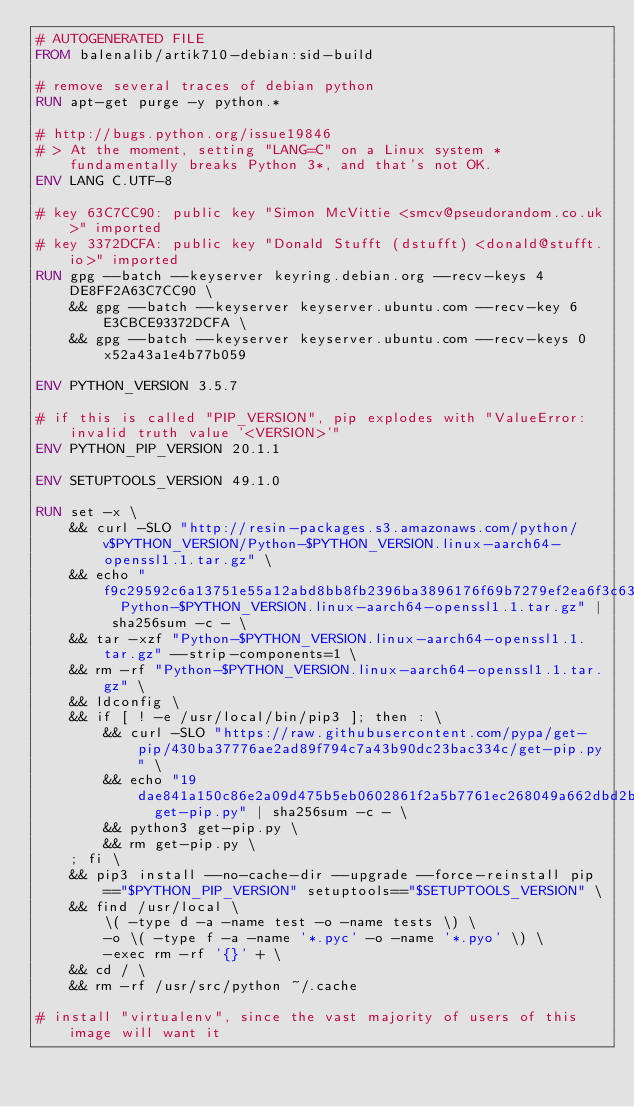Convert code to text. <code><loc_0><loc_0><loc_500><loc_500><_Dockerfile_># AUTOGENERATED FILE
FROM balenalib/artik710-debian:sid-build

# remove several traces of debian python
RUN apt-get purge -y python.*

# http://bugs.python.org/issue19846
# > At the moment, setting "LANG=C" on a Linux system *fundamentally breaks Python 3*, and that's not OK.
ENV LANG C.UTF-8

# key 63C7CC90: public key "Simon McVittie <smcv@pseudorandom.co.uk>" imported
# key 3372DCFA: public key "Donald Stufft (dstufft) <donald@stufft.io>" imported
RUN gpg --batch --keyserver keyring.debian.org --recv-keys 4DE8FF2A63C7CC90 \
	&& gpg --batch --keyserver keyserver.ubuntu.com --recv-key 6E3CBCE93372DCFA \
	&& gpg --batch --keyserver keyserver.ubuntu.com --recv-keys 0x52a43a1e4b77b059

ENV PYTHON_VERSION 3.5.7

# if this is called "PIP_VERSION", pip explodes with "ValueError: invalid truth value '<VERSION>'"
ENV PYTHON_PIP_VERSION 20.1.1

ENV SETUPTOOLS_VERSION 49.1.0

RUN set -x \
	&& curl -SLO "http://resin-packages.s3.amazonaws.com/python/v$PYTHON_VERSION/Python-$PYTHON_VERSION.linux-aarch64-openssl1.1.tar.gz" \
	&& echo "f9c29592c6a13751e55a12abd8bb8fb2396ba3896176f69b7279ef2ea6f3c639  Python-$PYTHON_VERSION.linux-aarch64-openssl1.1.tar.gz" | sha256sum -c - \
	&& tar -xzf "Python-$PYTHON_VERSION.linux-aarch64-openssl1.1.tar.gz" --strip-components=1 \
	&& rm -rf "Python-$PYTHON_VERSION.linux-aarch64-openssl1.1.tar.gz" \
	&& ldconfig \
	&& if [ ! -e /usr/local/bin/pip3 ]; then : \
		&& curl -SLO "https://raw.githubusercontent.com/pypa/get-pip/430ba37776ae2ad89f794c7a43b90dc23bac334c/get-pip.py" \
		&& echo "19dae841a150c86e2a09d475b5eb0602861f2a5b7761ec268049a662dbd2bd0c  get-pip.py" | sha256sum -c - \
		&& python3 get-pip.py \
		&& rm get-pip.py \
	; fi \
	&& pip3 install --no-cache-dir --upgrade --force-reinstall pip=="$PYTHON_PIP_VERSION" setuptools=="$SETUPTOOLS_VERSION" \
	&& find /usr/local \
		\( -type d -a -name test -o -name tests \) \
		-o \( -type f -a -name '*.pyc' -o -name '*.pyo' \) \
		-exec rm -rf '{}' + \
	&& cd / \
	&& rm -rf /usr/src/python ~/.cache

# install "virtualenv", since the vast majority of users of this image will want it</code> 